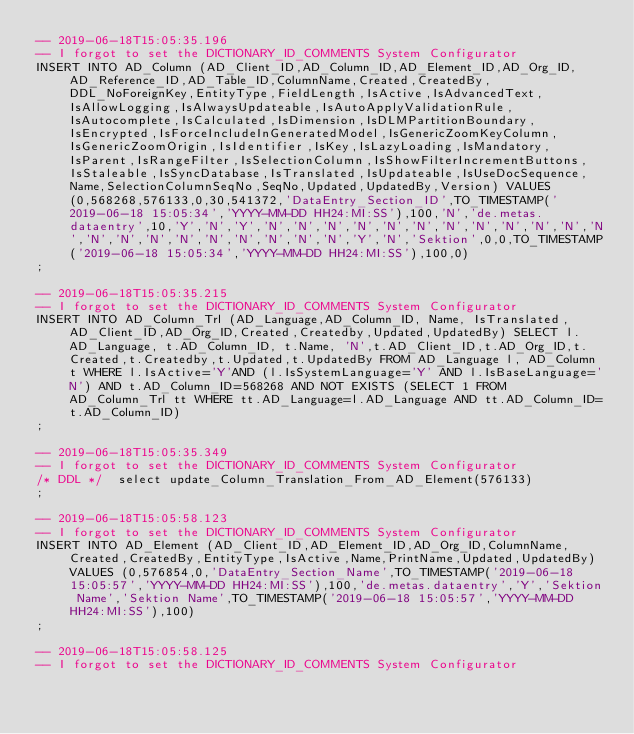Convert code to text. <code><loc_0><loc_0><loc_500><loc_500><_SQL_>-- 2019-06-18T15:05:35.196
-- I forgot to set the DICTIONARY_ID_COMMENTS System Configurator
INSERT INTO AD_Column (AD_Client_ID,AD_Column_ID,AD_Element_ID,AD_Org_ID,AD_Reference_ID,AD_Table_ID,ColumnName,Created,CreatedBy,DDL_NoForeignKey,EntityType,FieldLength,IsActive,IsAdvancedText,IsAllowLogging,IsAlwaysUpdateable,IsAutoApplyValidationRule,IsAutocomplete,IsCalculated,IsDimension,IsDLMPartitionBoundary,IsEncrypted,IsForceIncludeInGeneratedModel,IsGenericZoomKeyColumn,IsGenericZoomOrigin,IsIdentifier,IsKey,IsLazyLoading,IsMandatory,IsParent,IsRangeFilter,IsSelectionColumn,IsShowFilterIncrementButtons,IsStaleable,IsSyncDatabase,IsTranslated,IsUpdateable,IsUseDocSequence,Name,SelectionColumnSeqNo,SeqNo,Updated,UpdatedBy,Version) VALUES (0,568268,576133,0,30,541372,'DataEntry_Section_ID',TO_TIMESTAMP('2019-06-18 15:05:34','YYYY-MM-DD HH24:MI:SS'),100,'N','de.metas.dataentry',10,'Y','N','Y','N','N','N','N','N','N','N','N','N','N','N','N','N','N','N','N','N','N','N','N','N','Y','N','Sektion',0,0,TO_TIMESTAMP('2019-06-18 15:05:34','YYYY-MM-DD HH24:MI:SS'),100,0)
;

-- 2019-06-18T15:05:35.215
-- I forgot to set the DICTIONARY_ID_COMMENTS System Configurator
INSERT INTO AD_Column_Trl (AD_Language,AD_Column_ID, Name, IsTranslated,AD_Client_ID,AD_Org_ID,Created,Createdby,Updated,UpdatedBy) SELECT l.AD_Language, t.AD_Column_ID, t.Name, 'N',t.AD_Client_ID,t.AD_Org_ID,t.Created,t.Createdby,t.Updated,t.UpdatedBy FROM AD_Language l, AD_Column t WHERE l.IsActive='Y'AND (l.IsSystemLanguage='Y' AND l.IsBaseLanguage='N') AND t.AD_Column_ID=568268 AND NOT EXISTS (SELECT 1 FROM AD_Column_Trl tt WHERE tt.AD_Language=l.AD_Language AND tt.AD_Column_ID=t.AD_Column_ID)
;

-- 2019-06-18T15:05:35.349
-- I forgot to set the DICTIONARY_ID_COMMENTS System Configurator
/* DDL */  select update_Column_Translation_From_AD_Element(576133) 
;

-- 2019-06-18T15:05:58.123
-- I forgot to set the DICTIONARY_ID_COMMENTS System Configurator
INSERT INTO AD_Element (AD_Client_ID,AD_Element_ID,AD_Org_ID,ColumnName,Created,CreatedBy,EntityType,IsActive,Name,PrintName,Updated,UpdatedBy) VALUES (0,576854,0,'DataEntry_Section_Name',TO_TIMESTAMP('2019-06-18 15:05:57','YYYY-MM-DD HH24:MI:SS'),100,'de.metas.dataentry','Y','Sektion Name','Sektion Name',TO_TIMESTAMP('2019-06-18 15:05:57','YYYY-MM-DD HH24:MI:SS'),100)
;

-- 2019-06-18T15:05:58.125
-- I forgot to set the DICTIONARY_ID_COMMENTS System Configurator</code> 